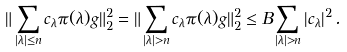<formula> <loc_0><loc_0><loc_500><loc_500>\| \sum _ { | \lambda | \leq n } c _ { \lambda } \pi ( \lambda ) g \| _ { 2 } ^ { 2 } & = \| \sum _ { | \lambda | > n } c _ { \lambda } \pi ( \lambda ) g \| _ { 2 } ^ { 2 } \leq B \sum _ { | \lambda | > n } | c _ { \lambda } | ^ { 2 } \, .</formula> 